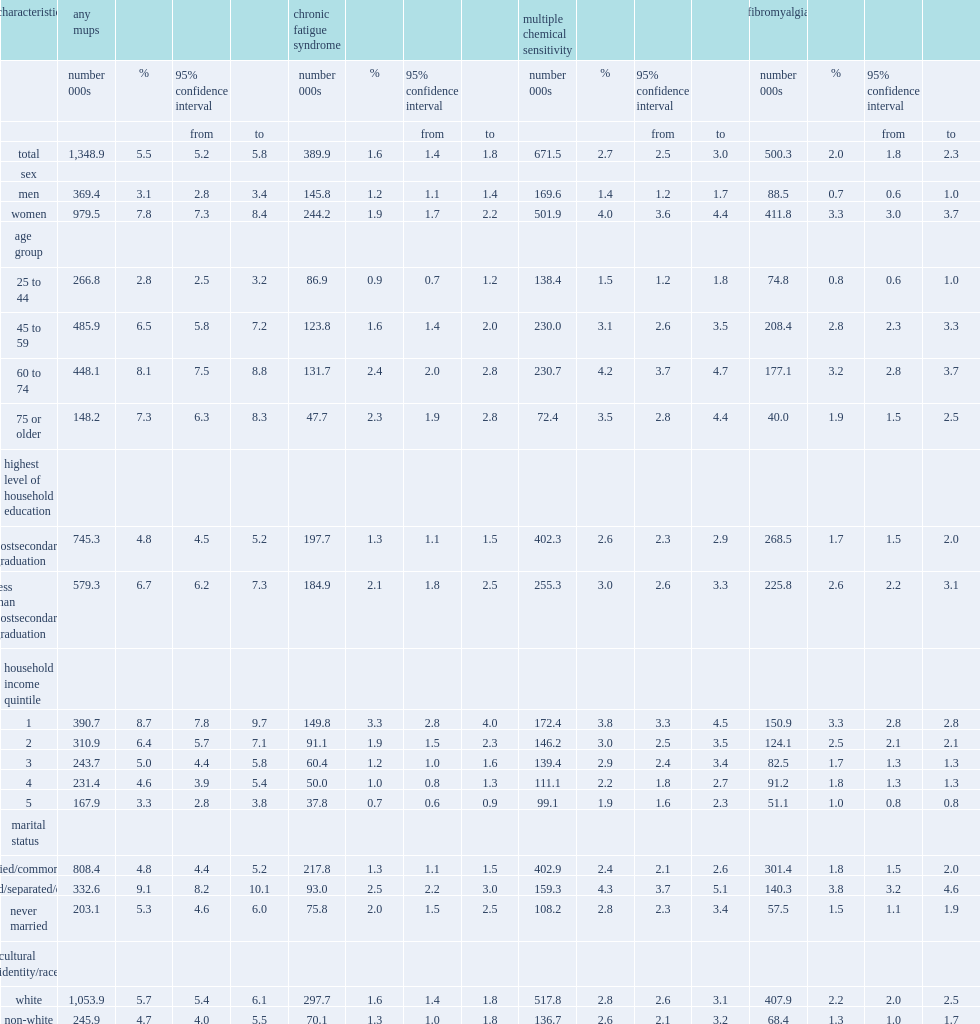In 2014, how many percent of canadians aged 25 or older-1.3 million―reported one or more of the three mups conditions? 5.5. In 2014, how many percent of canadians aged 25 or older reported chronic fatigue syndrome? 1.6. In 2014, how many percent of canadians aged 25 or older reported chronic fatigue syndrome? 2. In 2014, how many percent of canadians aged 25 or older reported multiple chemical sensitivity? 2.7. In 2014, among canadian aged 25 or older, how many times were women more likely to report each disease than men? 2.516129. What is the age group with the lowest overall prevalence of mups? 25 to 44. Which education level is more likely to have chronic fatigue syndrome, individuals without postsecondary graduation or those with a postsecondary diploma or degree? Less than postsecondary graduation. Which education level is more likely to have fibromyalgia, individuals without postsecondary graduation or those with a postsecondary diploma or degree? Less than postsecondary graduation. What was the percent of people in the lowest household income quintile that had chronic fatigue syndrome? 3.3. What was the percent of people in the highest income quintile had chronic fatigue syndrome? 0.7. How likely were divorced/separated/widowed individuals to report mups then those who were married/common-law ? 1.895833. Which race is more likely to report fibromyalgia, white canadians or non-white? White. 